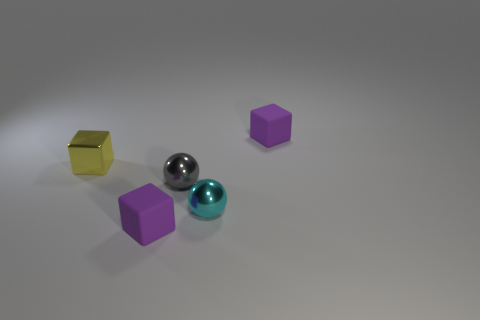How does the lighting affect the appearance of the objects? The lighting in the image creates subtle shadows and highlights that enhance the three-dimensional appearance of the objects. The directional light seems to be coming from the upper left side, causing the right sides of the objects to be in shadow. The reflective surfaces, like the metallic object and the floor, show gleams of light that indicate the smoothness and texture of their materials. 